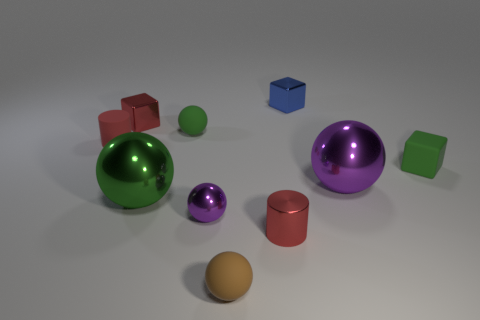Subtract all cylinders. How many objects are left? 8 Subtract 0 blue balls. How many objects are left? 10 Subtract all large yellow metal balls. Subtract all tiny red rubber things. How many objects are left? 9 Add 2 small green matte things. How many small green matte things are left? 4 Add 3 brown objects. How many brown objects exist? 4 